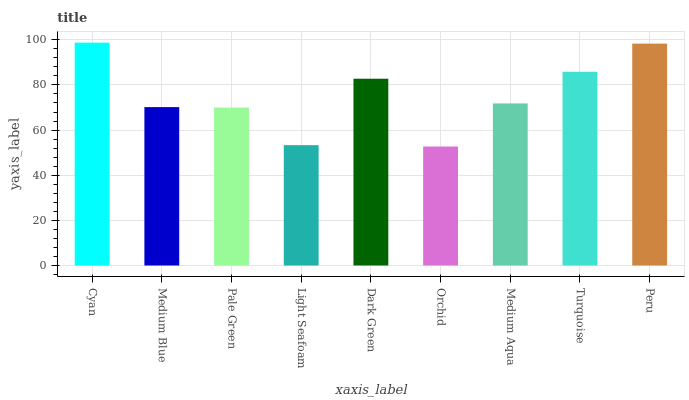Is Orchid the minimum?
Answer yes or no. Yes. Is Cyan the maximum?
Answer yes or no. Yes. Is Medium Blue the minimum?
Answer yes or no. No. Is Medium Blue the maximum?
Answer yes or no. No. Is Cyan greater than Medium Blue?
Answer yes or no. Yes. Is Medium Blue less than Cyan?
Answer yes or no. Yes. Is Medium Blue greater than Cyan?
Answer yes or no. No. Is Cyan less than Medium Blue?
Answer yes or no. No. Is Medium Aqua the high median?
Answer yes or no. Yes. Is Medium Aqua the low median?
Answer yes or no. Yes. Is Peru the high median?
Answer yes or no. No. Is Medium Blue the low median?
Answer yes or no. No. 